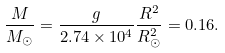Convert formula to latex. <formula><loc_0><loc_0><loc_500><loc_500>\frac { M } { M _ { \odot } } = \frac { g } { 2 . 7 4 \times 1 0 ^ { 4 } } \frac { R ^ { 2 } } { R _ { \odot } ^ { 2 } } = 0 . 1 6 .</formula> 